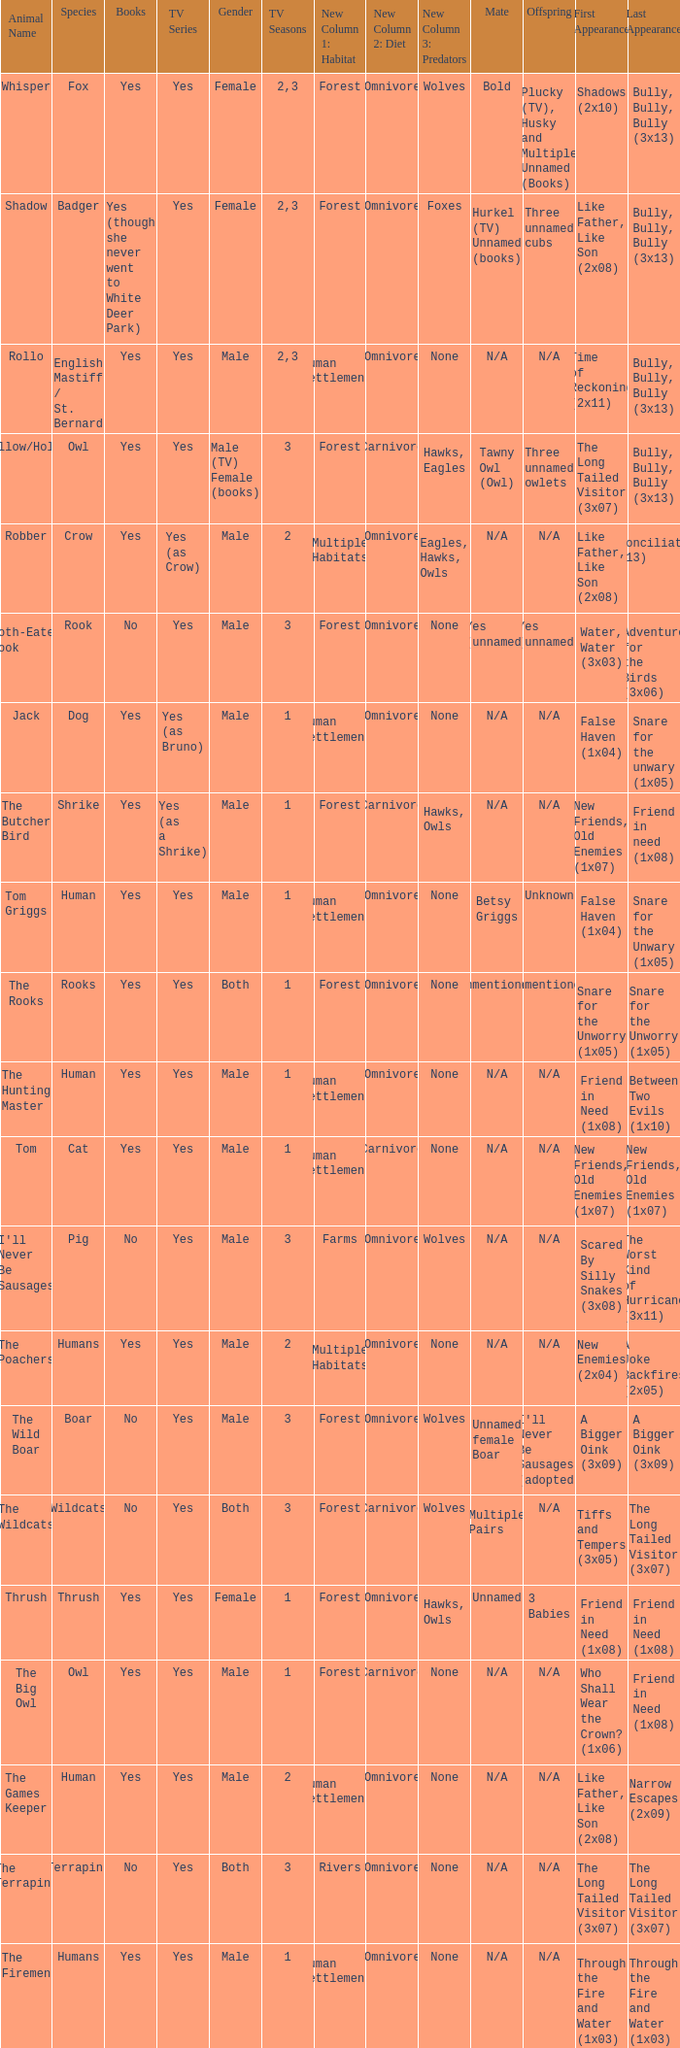What show has a boar? Yes. 